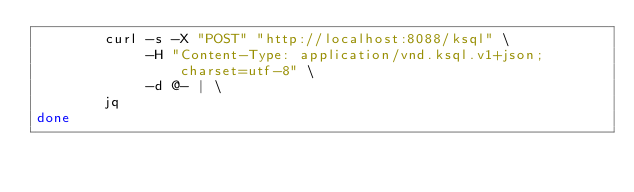Convert code to text. <code><loc_0><loc_0><loc_500><loc_500><_Bash_>        curl -s -X "POST" "http://localhost:8088/ksql" \
             -H "Content-Type: application/vnd.ksql.v1+json; charset=utf-8" \
             -d @- | \
        jq
done</code> 